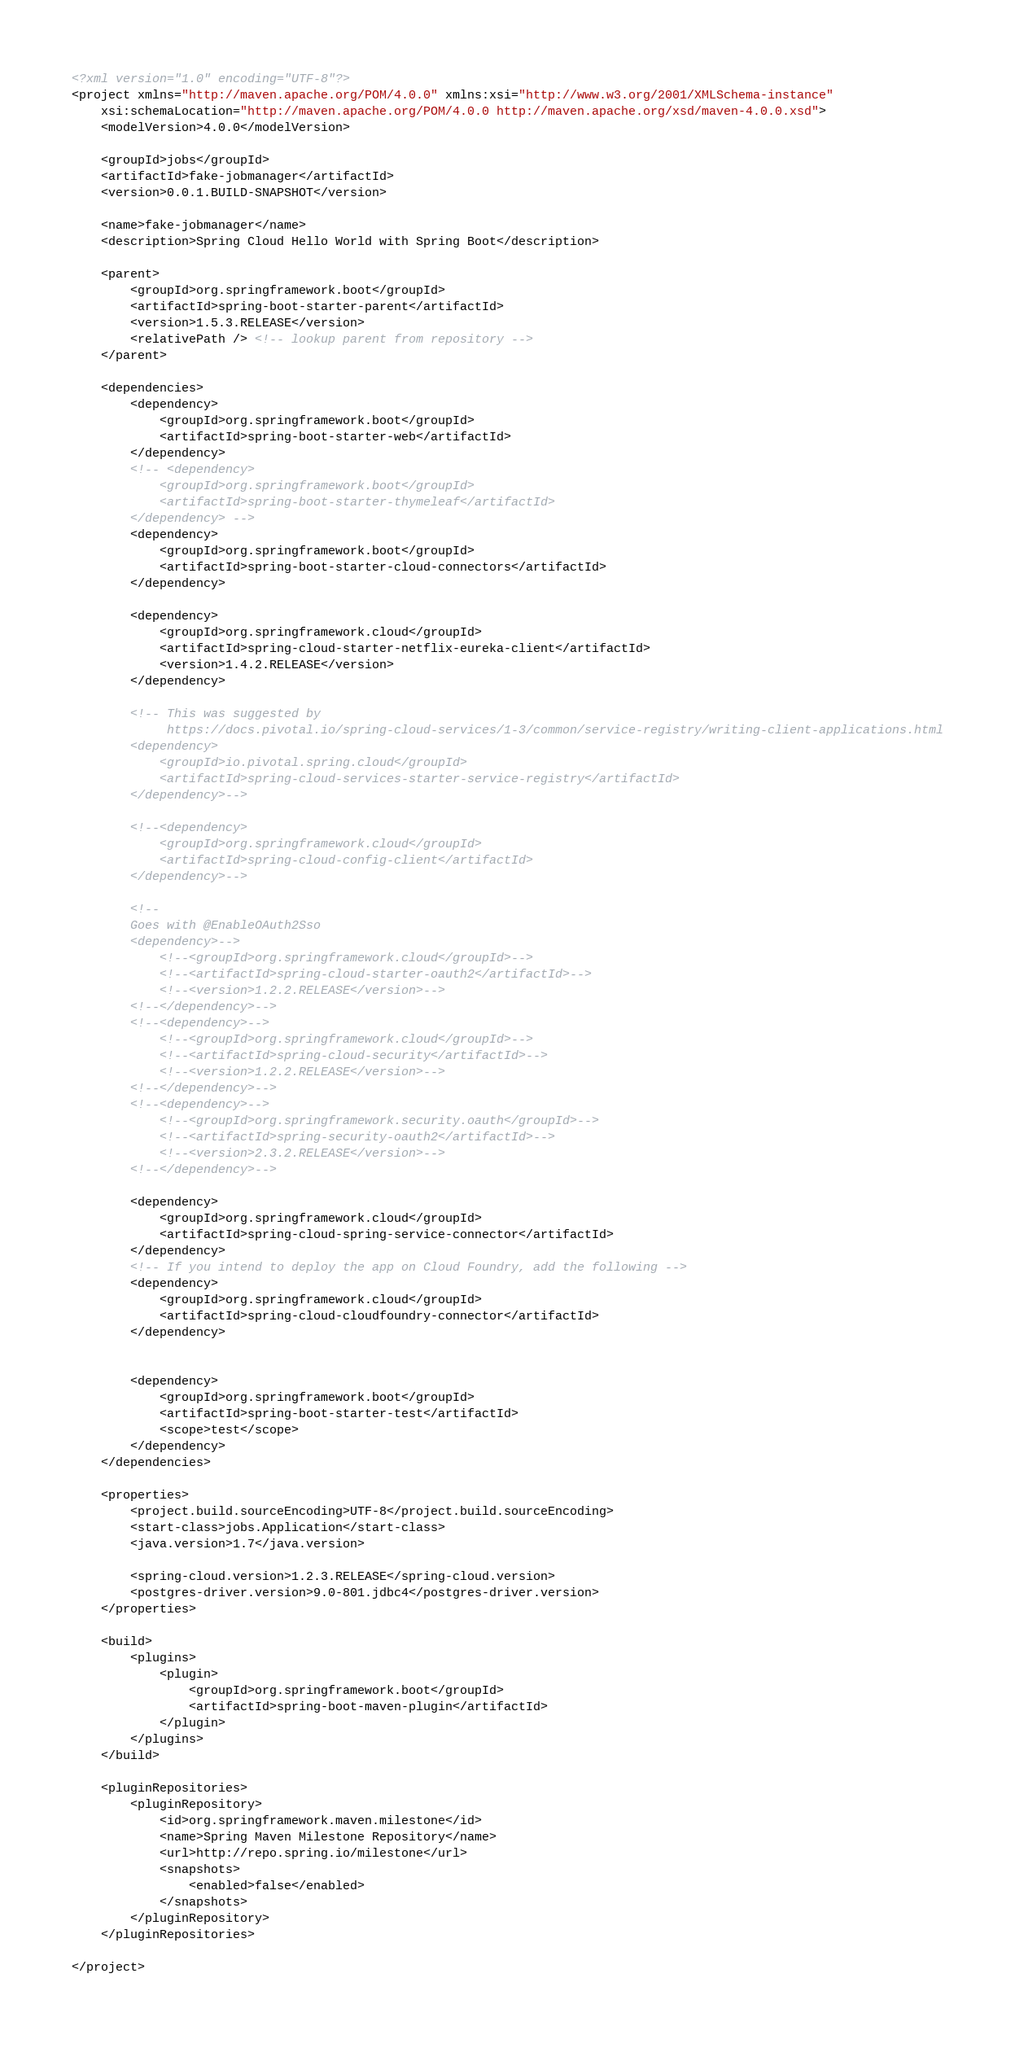Convert code to text. <code><loc_0><loc_0><loc_500><loc_500><_XML_><?xml version="1.0" encoding="UTF-8"?>
<project xmlns="http://maven.apache.org/POM/4.0.0" xmlns:xsi="http://www.w3.org/2001/XMLSchema-instance"
	xsi:schemaLocation="http://maven.apache.org/POM/4.0.0 http://maven.apache.org/xsd/maven-4.0.0.xsd">
	<modelVersion>4.0.0</modelVersion>

	<groupId>jobs</groupId>
	<artifactId>fake-jobmanager</artifactId>
	<version>0.0.1.BUILD-SNAPSHOT</version>

	<name>fake-jobmanager</name>
	<description>Spring Cloud Hello World with Spring Boot</description>

	<parent>
		<groupId>org.springframework.boot</groupId>
		<artifactId>spring-boot-starter-parent</artifactId>
		<version>1.5.3.RELEASE</version>
		<relativePath /> <!-- lookup parent from repository -->
	</parent>

	<dependencies>
		<dependency>
			<groupId>org.springframework.boot</groupId>
			<artifactId>spring-boot-starter-web</artifactId>
		</dependency>
		<!-- <dependency>
			<groupId>org.springframework.boot</groupId>
			<artifactId>spring-boot-starter-thymeleaf</artifactId>
		</dependency> -->
		<dependency>
			<groupId>org.springframework.boot</groupId>
			<artifactId>spring-boot-starter-cloud-connectors</artifactId>
		</dependency>

		<dependency>
			<groupId>org.springframework.cloud</groupId>
			<artifactId>spring-cloud-starter-netflix-eureka-client</artifactId>
			<version>1.4.2.RELEASE</version>
		</dependency>

		<!-- This was suggested by
		     https://docs.pivotal.io/spring-cloud-services/1-3/common/service-registry/writing-client-applications.html
		<dependency>
			<groupId>io.pivotal.spring.cloud</groupId>
			<artifactId>spring-cloud-services-starter-service-registry</artifactId>
		</dependency>-->

		<!--<dependency>
			<groupId>org.springframework.cloud</groupId>
			<artifactId>spring-cloud-config-client</artifactId>
		</dependency>-->

		<!--
		Goes with @EnableOAuth2Sso
		<dependency>-->
			<!--<groupId>org.springframework.cloud</groupId>-->
			<!--<artifactId>spring-cloud-starter-oauth2</artifactId>-->
			<!--<version>1.2.2.RELEASE</version>-->
		<!--</dependency>-->
		<!--<dependency>-->
			<!--<groupId>org.springframework.cloud</groupId>-->
			<!--<artifactId>spring-cloud-security</artifactId>-->
			<!--<version>1.2.2.RELEASE</version>-->
		<!--</dependency>-->
		<!--<dependency>-->
			<!--<groupId>org.springframework.security.oauth</groupId>-->
			<!--<artifactId>spring-security-oauth2</artifactId>-->
			<!--<version>2.3.2.RELEASE</version>-->
		<!--</dependency>-->

		<dependency>
			<groupId>org.springframework.cloud</groupId>
			<artifactId>spring-cloud-spring-service-connector</artifactId>
		</dependency>
		<!-- If you intend to deploy the app on Cloud Foundry, add the following -->
		<dependency>
			<groupId>org.springframework.cloud</groupId>
			<artifactId>spring-cloud-cloudfoundry-connector</artifactId>
		</dependency>


		<dependency>
			<groupId>org.springframework.boot</groupId>
			<artifactId>spring-boot-starter-test</artifactId>
			<scope>test</scope>
		</dependency>
	</dependencies>

	<properties>
		<project.build.sourceEncoding>UTF-8</project.build.sourceEncoding>
		<start-class>jobs.Application</start-class>
		<java.version>1.7</java.version>

		<spring-cloud.version>1.2.3.RELEASE</spring-cloud.version>
		<postgres-driver.version>9.0-801.jdbc4</postgres-driver.version>
	</properties>

	<build>
		<plugins>
			<plugin>
				<groupId>org.springframework.boot</groupId>
				<artifactId>spring-boot-maven-plugin</artifactId>
			</plugin>
		</plugins>
	</build>

	<pluginRepositories>
		<pluginRepository>
			<id>org.springframework.maven.milestone</id>
			<name>Spring Maven Milestone Repository</name>
			<url>http://repo.spring.io/milestone</url>
			<snapshots>
				<enabled>false</enabled>
			</snapshots>
		</pluginRepository>
	</pluginRepositories>

</project>
</code> 